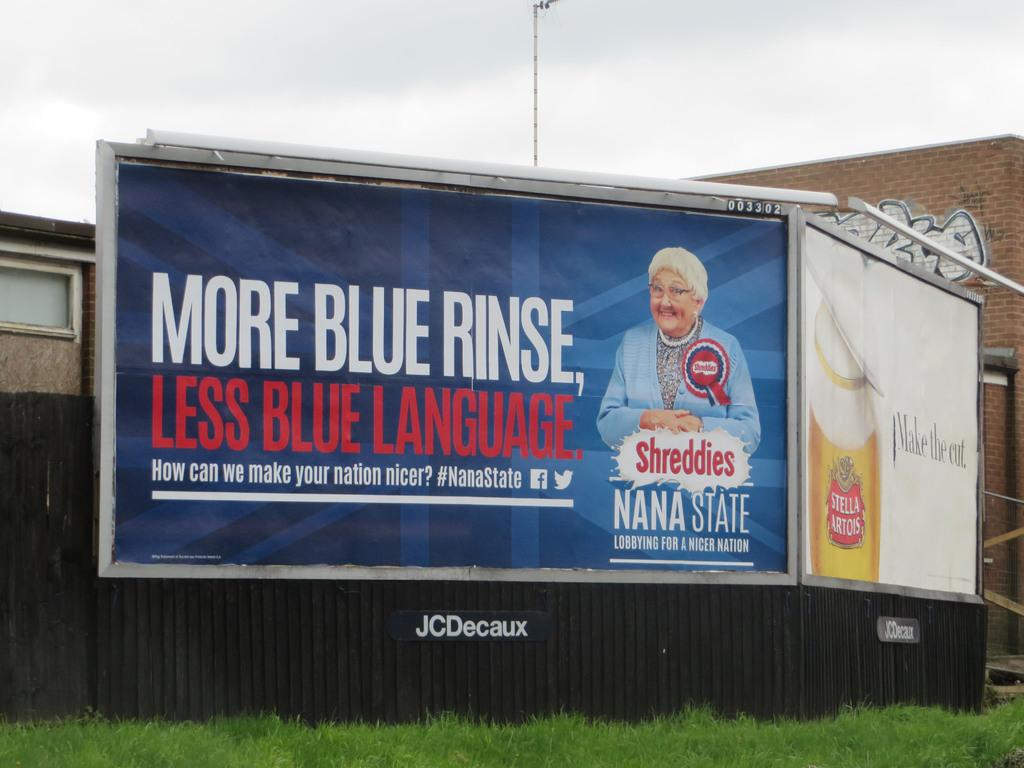<image>
Give a short and clear explanation of the subsequent image. Bilboard advertising Nana State which is lobying for a nicer nation, "More blue rinse, less blue language. 